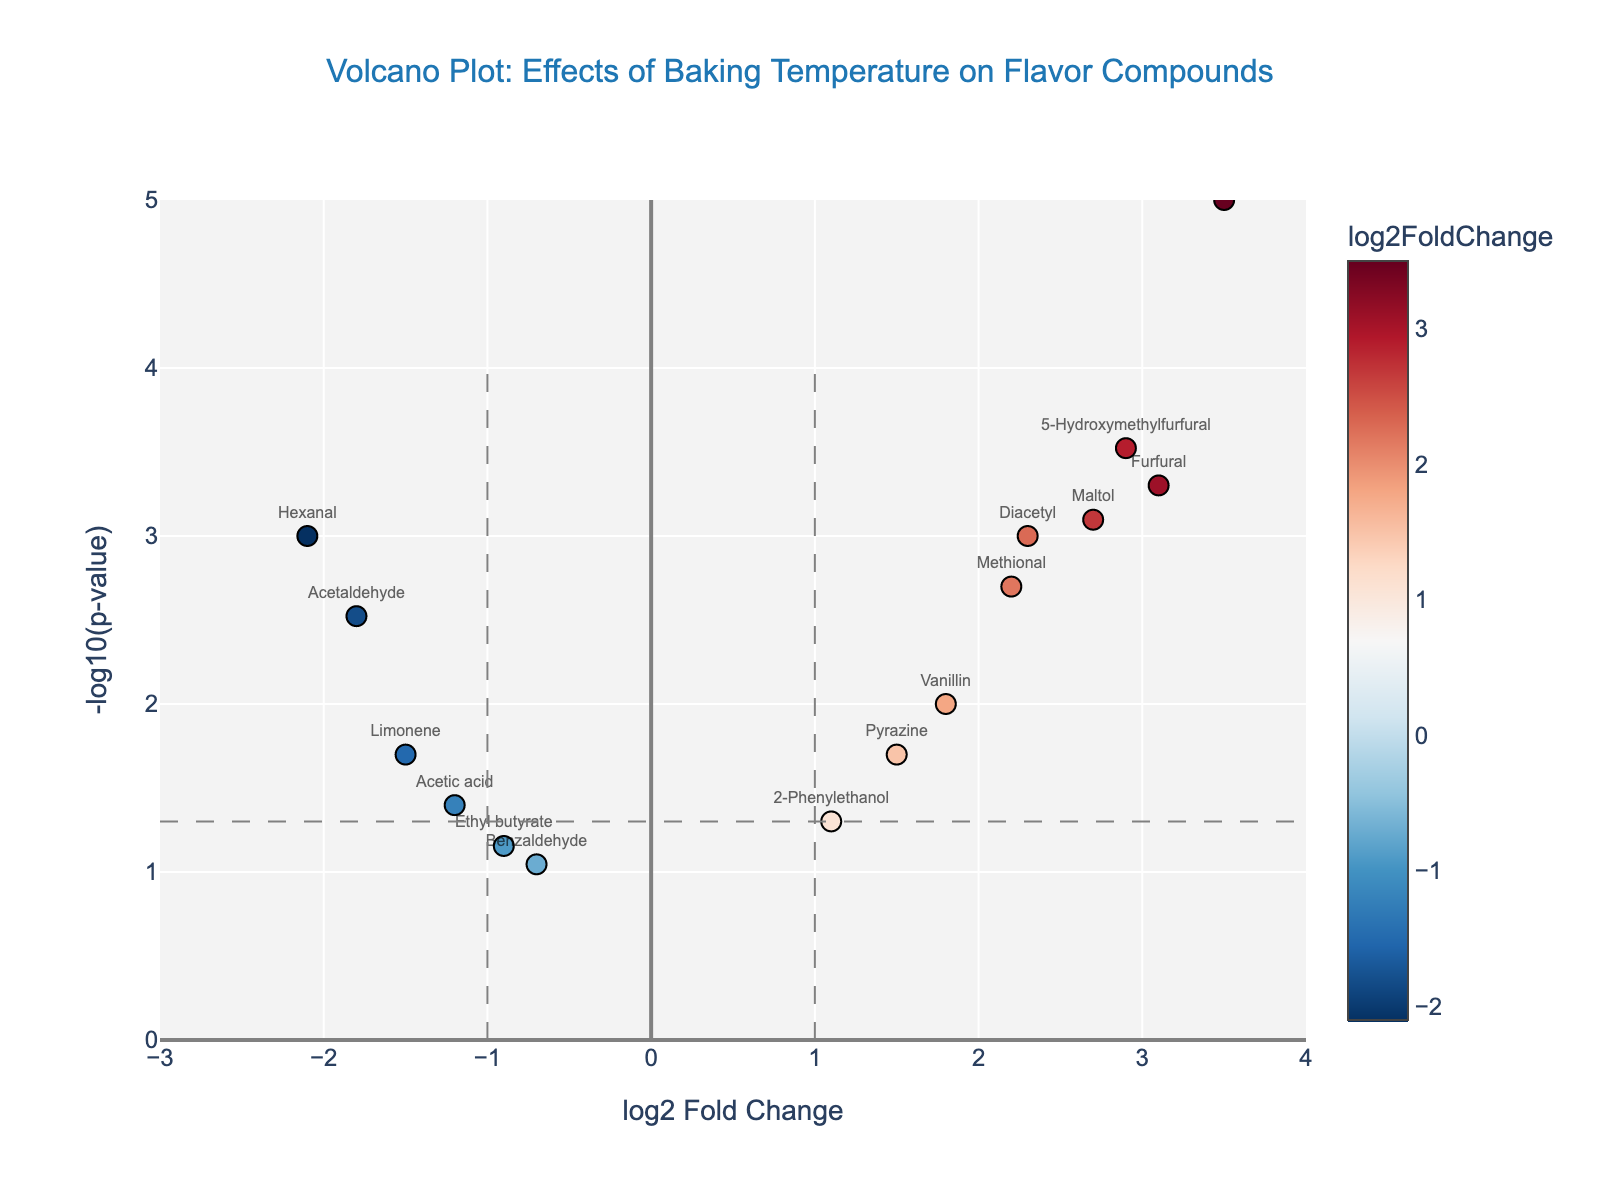what is the highest log2 Fold Change observed? Find the data point with the highest value on the x-axis. The highest point is 2-Acetyl-1-pyrroline with a log2 Fold Change of 3.5.
Answer: 3.5 which compound has the smallest p-value? Check for the point with the highest -log10(p-value) on the y-axis. 2-Acetyl-1-pyrroline has the smallest p-value because it's at the highest point.
Answer: 2-Acetyl-1-pyrroline how many compounds have a log2 Fold Change greater than 1 and a p-value less than 0.05? Look for points right of the vertical line at log2 Fold Change = 1 and above the horizontal line at -log10(p-value) = 1.3. The compounds fulfilling these criteria are Furfural, Methional, and 2-Acetyl-1-pyrroline.
Answer: 3 which compounds have decreased in abundance under different baking temperatures? Find the compounds left of the vertical line at log2 Fold Change = -1. The compounds are Acetaldehyde, Acetic acid, Hexanal, and Limonene.
Answer: 4 what is the log2 Fold Change and p-value for Furfural? Locate Furfural’s position on the plot. According to the hover text, the log2FC is 3.1 and the p-value is 0.0005.
Answer: log2 Fold Change: 3.1, p-value: 0.0005 name a compound with a log2 Fold Change between -1 and 1, and p-value more than 0.05 Look for a point within the range of -1 and 1 for log2 Fold Change and below -log10(p-value) = 1.3. The compound Benzaldehyde falls within these criteria.
Answer: Benzaldehyde which compound has the highest -log10(p-value)? Find which point is at the highest point on the y-axis. The highest point is for 2-Acetyl-1-pyrroline.
Answer: 2-Acetyl-1-pyrroline compare the abundance changes of Limonene and Vanillin. Which one increased and which one decreased? Limonene is left of log2 Fold Change = -1 indicating a decrease. Vanillin is right of log2 Fold Change = 1 indicating an increase.
Answer: Limonene decreased, Vanillin increased which compound showed the largest decrease in abundance? Identify the lowest value on the log2 Fold Change axis. Hexanal has the lowest value at -2.1.
Answer: Hexanal 